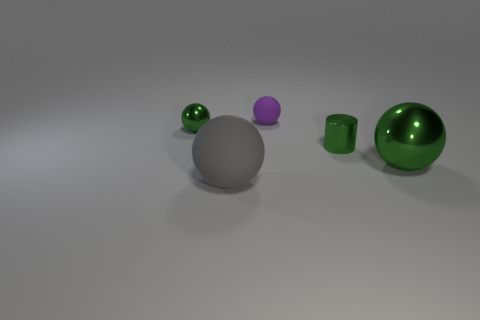Add 2 tiny gray shiny balls. How many objects exist? 7 Subtract all spheres. How many objects are left? 1 Add 1 tiny purple objects. How many tiny purple objects are left? 2 Add 5 small balls. How many small balls exist? 7 Subtract 0 red cubes. How many objects are left? 5 Subtract all green shiny cylinders. Subtract all rubber spheres. How many objects are left? 2 